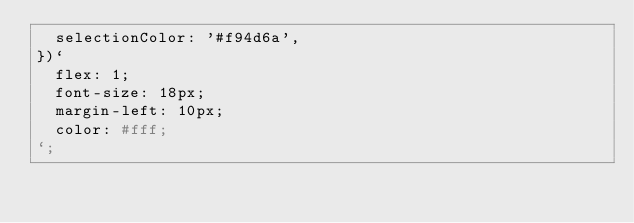<code> <loc_0><loc_0><loc_500><loc_500><_JavaScript_>  selectionColor: '#f94d6a',
})`
  flex: 1;
  font-size: 18px;
  margin-left: 10px;
  color: #fff;
`;
</code> 